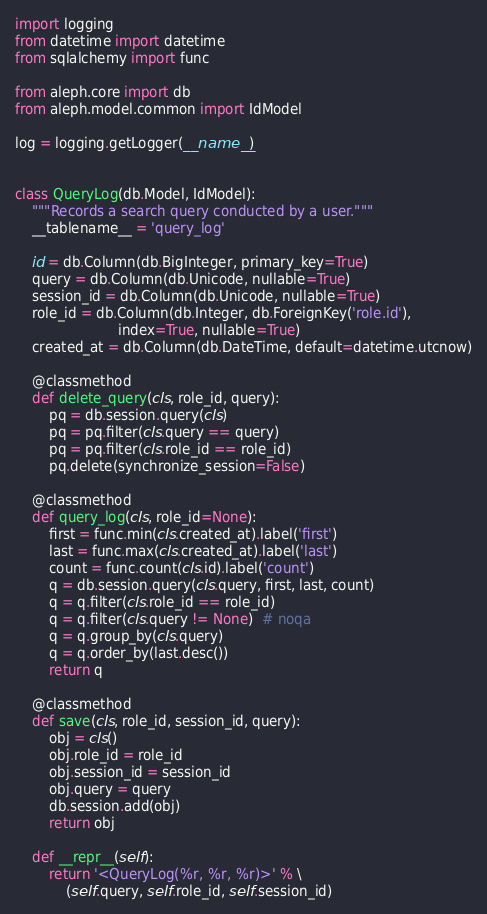Convert code to text. <code><loc_0><loc_0><loc_500><loc_500><_Python_>import logging
from datetime import datetime
from sqlalchemy import func

from aleph.core import db
from aleph.model.common import IdModel

log = logging.getLogger(__name__)


class QueryLog(db.Model, IdModel):
    """Records a search query conducted by a user."""
    __tablename__ = 'query_log'

    id = db.Column(db.BigInteger, primary_key=True)
    query = db.Column(db.Unicode, nullable=True)
    session_id = db.Column(db.Unicode, nullable=True)
    role_id = db.Column(db.Integer, db.ForeignKey('role.id'),
                        index=True, nullable=True)
    created_at = db.Column(db.DateTime, default=datetime.utcnow)

    @classmethod
    def delete_query(cls, role_id, query):
        pq = db.session.query(cls)
        pq = pq.filter(cls.query == query)
        pq = pq.filter(cls.role_id == role_id)
        pq.delete(synchronize_session=False)

    @classmethod
    def query_log(cls, role_id=None):
        first = func.min(cls.created_at).label('first')
        last = func.max(cls.created_at).label('last')
        count = func.count(cls.id).label('count')
        q = db.session.query(cls.query, first, last, count)
        q = q.filter(cls.role_id == role_id)
        q = q.filter(cls.query != None)  # noqa
        q = q.group_by(cls.query)
        q = q.order_by(last.desc())
        return q

    @classmethod
    def save(cls, role_id, session_id, query):
        obj = cls()
        obj.role_id = role_id
        obj.session_id = session_id
        obj.query = query
        db.session.add(obj)
        return obj

    def __repr__(self):
        return '<QueryLog(%r, %r, %r)>' % \
            (self.query, self.role_id, self.session_id)
</code> 